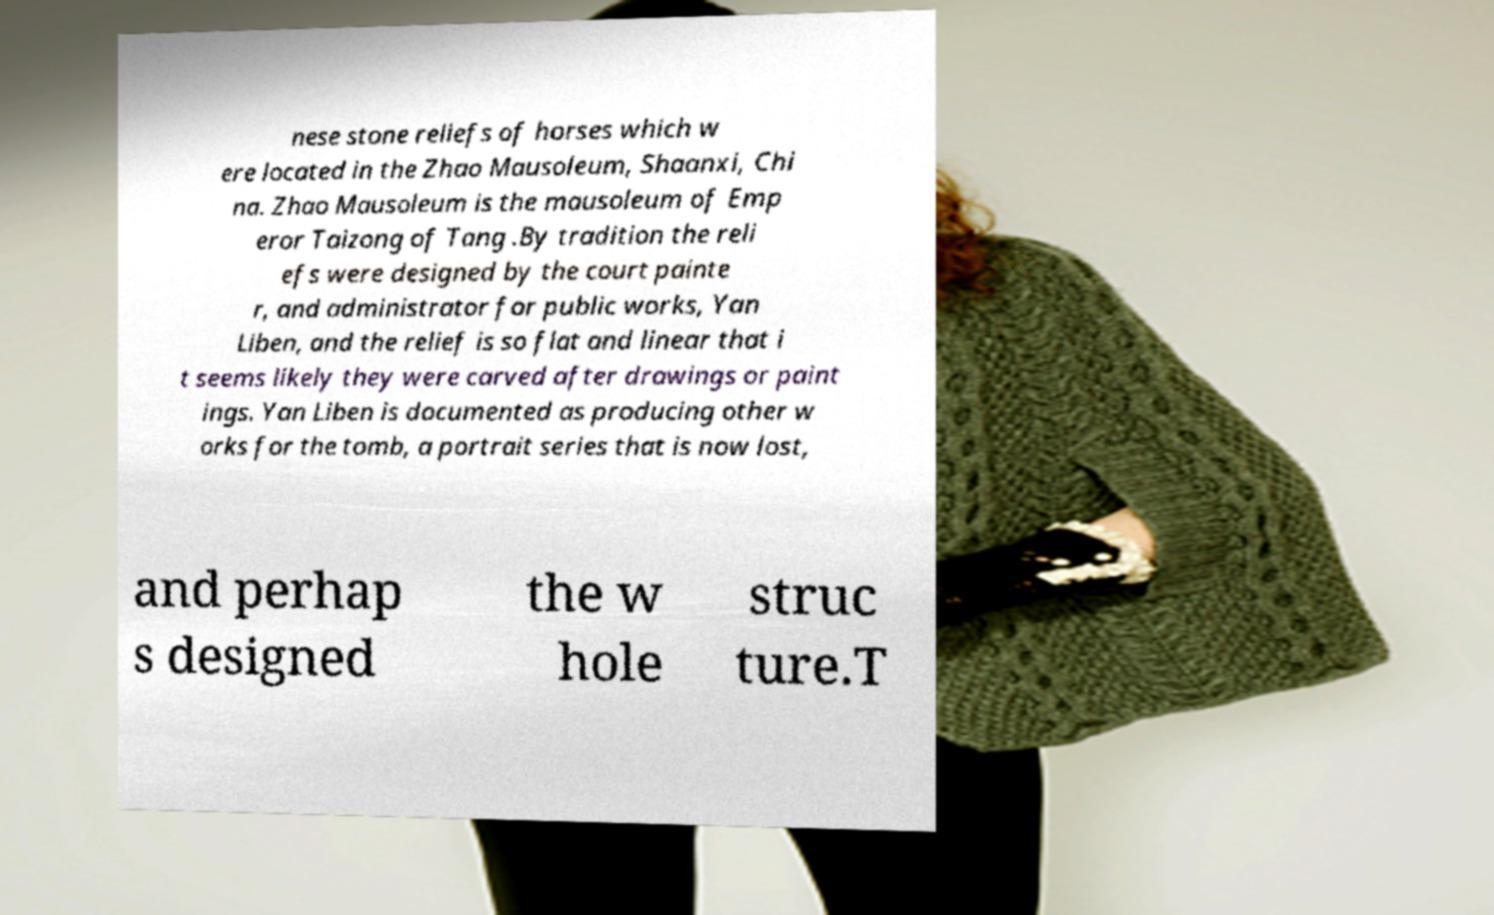Please read and relay the text visible in this image. What does it say? nese stone reliefs of horses which w ere located in the Zhao Mausoleum, Shaanxi, Chi na. Zhao Mausoleum is the mausoleum of Emp eror Taizong of Tang .By tradition the reli efs were designed by the court painte r, and administrator for public works, Yan Liben, and the relief is so flat and linear that i t seems likely they were carved after drawings or paint ings. Yan Liben is documented as producing other w orks for the tomb, a portrait series that is now lost, and perhap s designed the w hole struc ture.T 